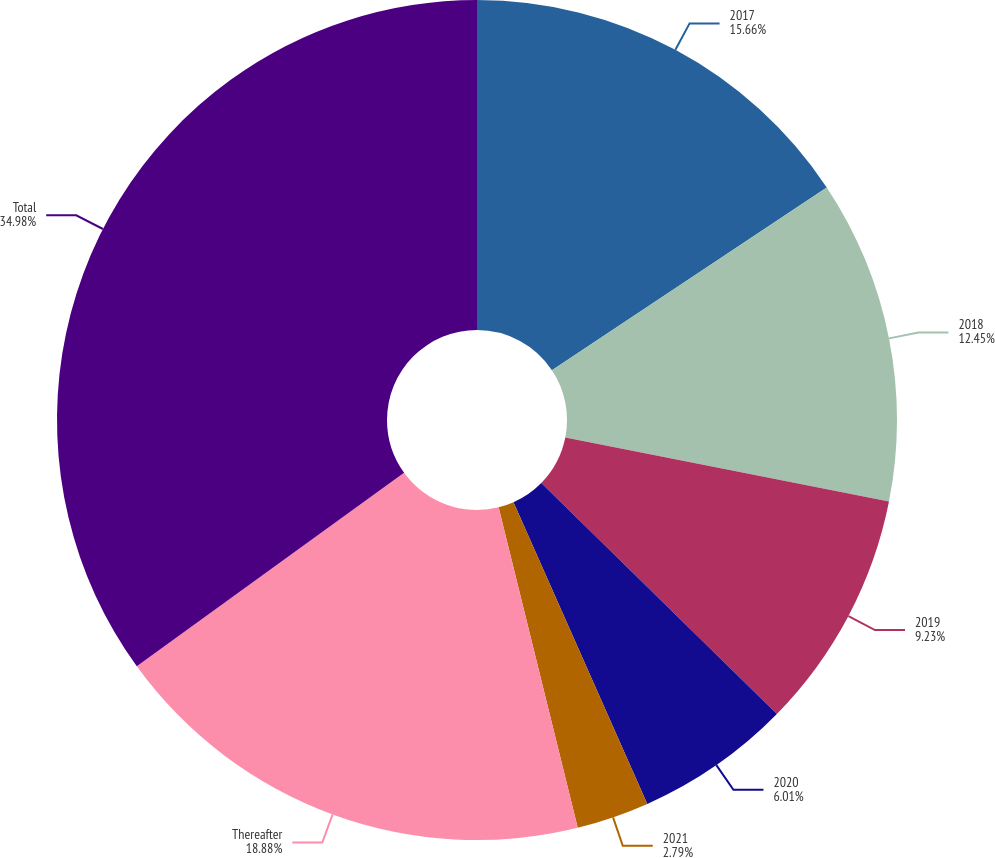<chart> <loc_0><loc_0><loc_500><loc_500><pie_chart><fcel>2017<fcel>2018<fcel>2019<fcel>2020<fcel>2021<fcel>Thereafter<fcel>Total<nl><fcel>15.66%<fcel>12.45%<fcel>9.23%<fcel>6.01%<fcel>2.79%<fcel>18.88%<fcel>34.97%<nl></chart> 